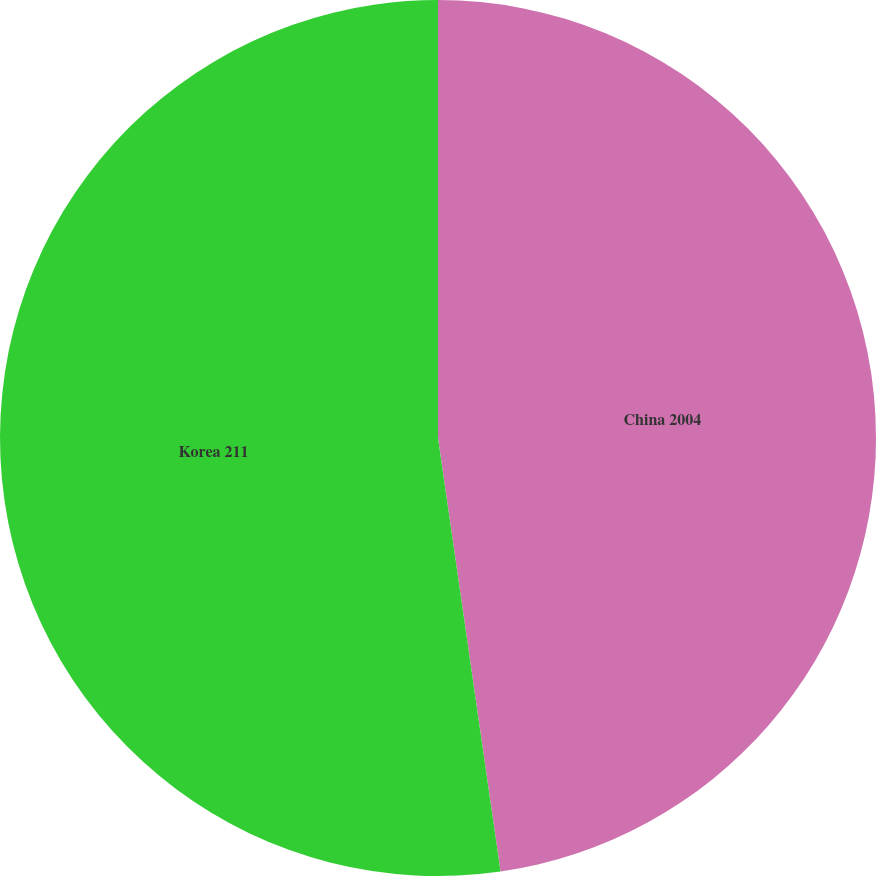<chart> <loc_0><loc_0><loc_500><loc_500><pie_chart><fcel>China 2004<fcel>Korea 211<nl><fcel>47.72%<fcel>52.28%<nl></chart> 